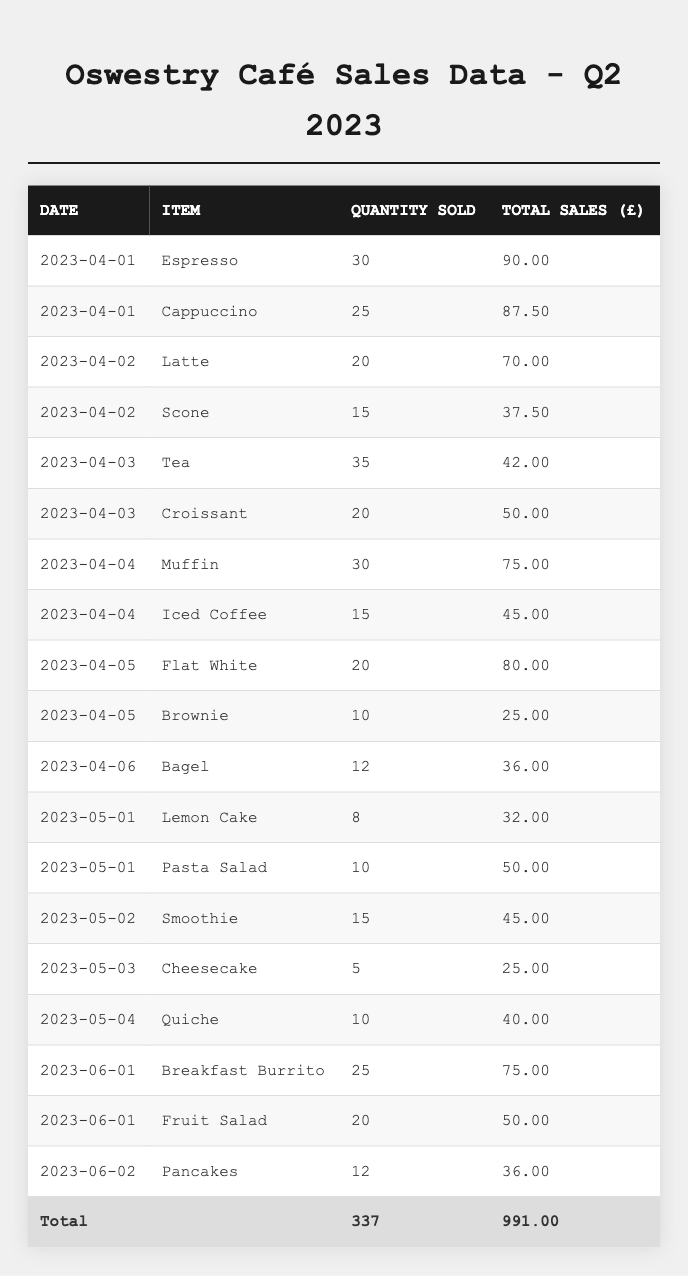What item had the highest total sales on April 1st? On April 1st, the items sold were Espresso with total sales of £90.00 and Cappuccino with total sales of £87.50. Therefore, Espresso had the highest total sales on that day.
Answer: Espresso How many units of Scone were sold? The table indicates that 15 Scones were sold on April 2nd, which gives the answer directly from the data.
Answer: 15 What were the total sales from the top three selling items in the table? The total sales for the top three selling items are Espresso (£90.00), Cappuccino (£87.50), and Latte (£70.00). Adding these amounts: 90 + 87.5 + 70 = £247.50.
Answer: £247.50 Which item sold the least quantity? Looking at all entries, Cheesecake was sold the least with 5 units sold on May 3rd, which is the lowest quantity compared to others listed in the table.
Answer: Cheesecake What is the average quantity sold of all items in May? In May, the items sold were Lemon Cake (8), Pasta Salad (10), Smoothie (15), Cheesecake (5), and Quiche (10). The total quantity is 8 + 10 + 15 + 5 + 10 = 48. There are 5 items, so the average is 48/5 = 9.6.
Answer: 9.6 Was there any day when total sales exceeded £100? By examining the sales data, no single day's sales amounts exceed £100; the maximum on the listed days is £90.00 for Espresso on April 1st. Thus, the statement is true.
Answer: No On which date was the total quantity sold the highest? To determine this, we review the quantities sold on each date. April 3rd had 35 (Tea) + 20 (Croissant) = 55 units, which is the highest total for any date listed in the table.
Answer: April 3rd How much more did the Iced Coffee bring in total sales compared to the Brownie? The total sales for Iced Coffee are £45.00, while for Brownie, it's £25.00. The difference in total sales is £45.00 - £25.00 = £20.00.
Answer: £20.00 What percentage of total sales in June came from the Breakfast Burrito? The total sales in June are £75.00 (Breakfast Burrito) + £50.00 (Fruit Salad) + £36.00 (Pancakes) = £161.00. The percentage from the Breakfast Burrito is (75/161) * 100 = 46.6%.
Answer: 46.6% What is the total sales for all items sold in the second quarter? Summing all total sales amount in the table, we get £991.00 as the total sales for the second quarter throughout all the days and items listed.
Answer: £991.00 